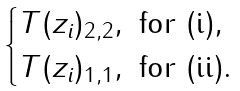<formula> <loc_0><loc_0><loc_500><loc_500>\begin{cases} T ( z _ { i } ) _ { 2 , 2 } , \text { for (i)} , \\ T ( z _ { i } ) _ { 1 , 1 } , \text { for (ii)} . \\ \end{cases}</formula> 